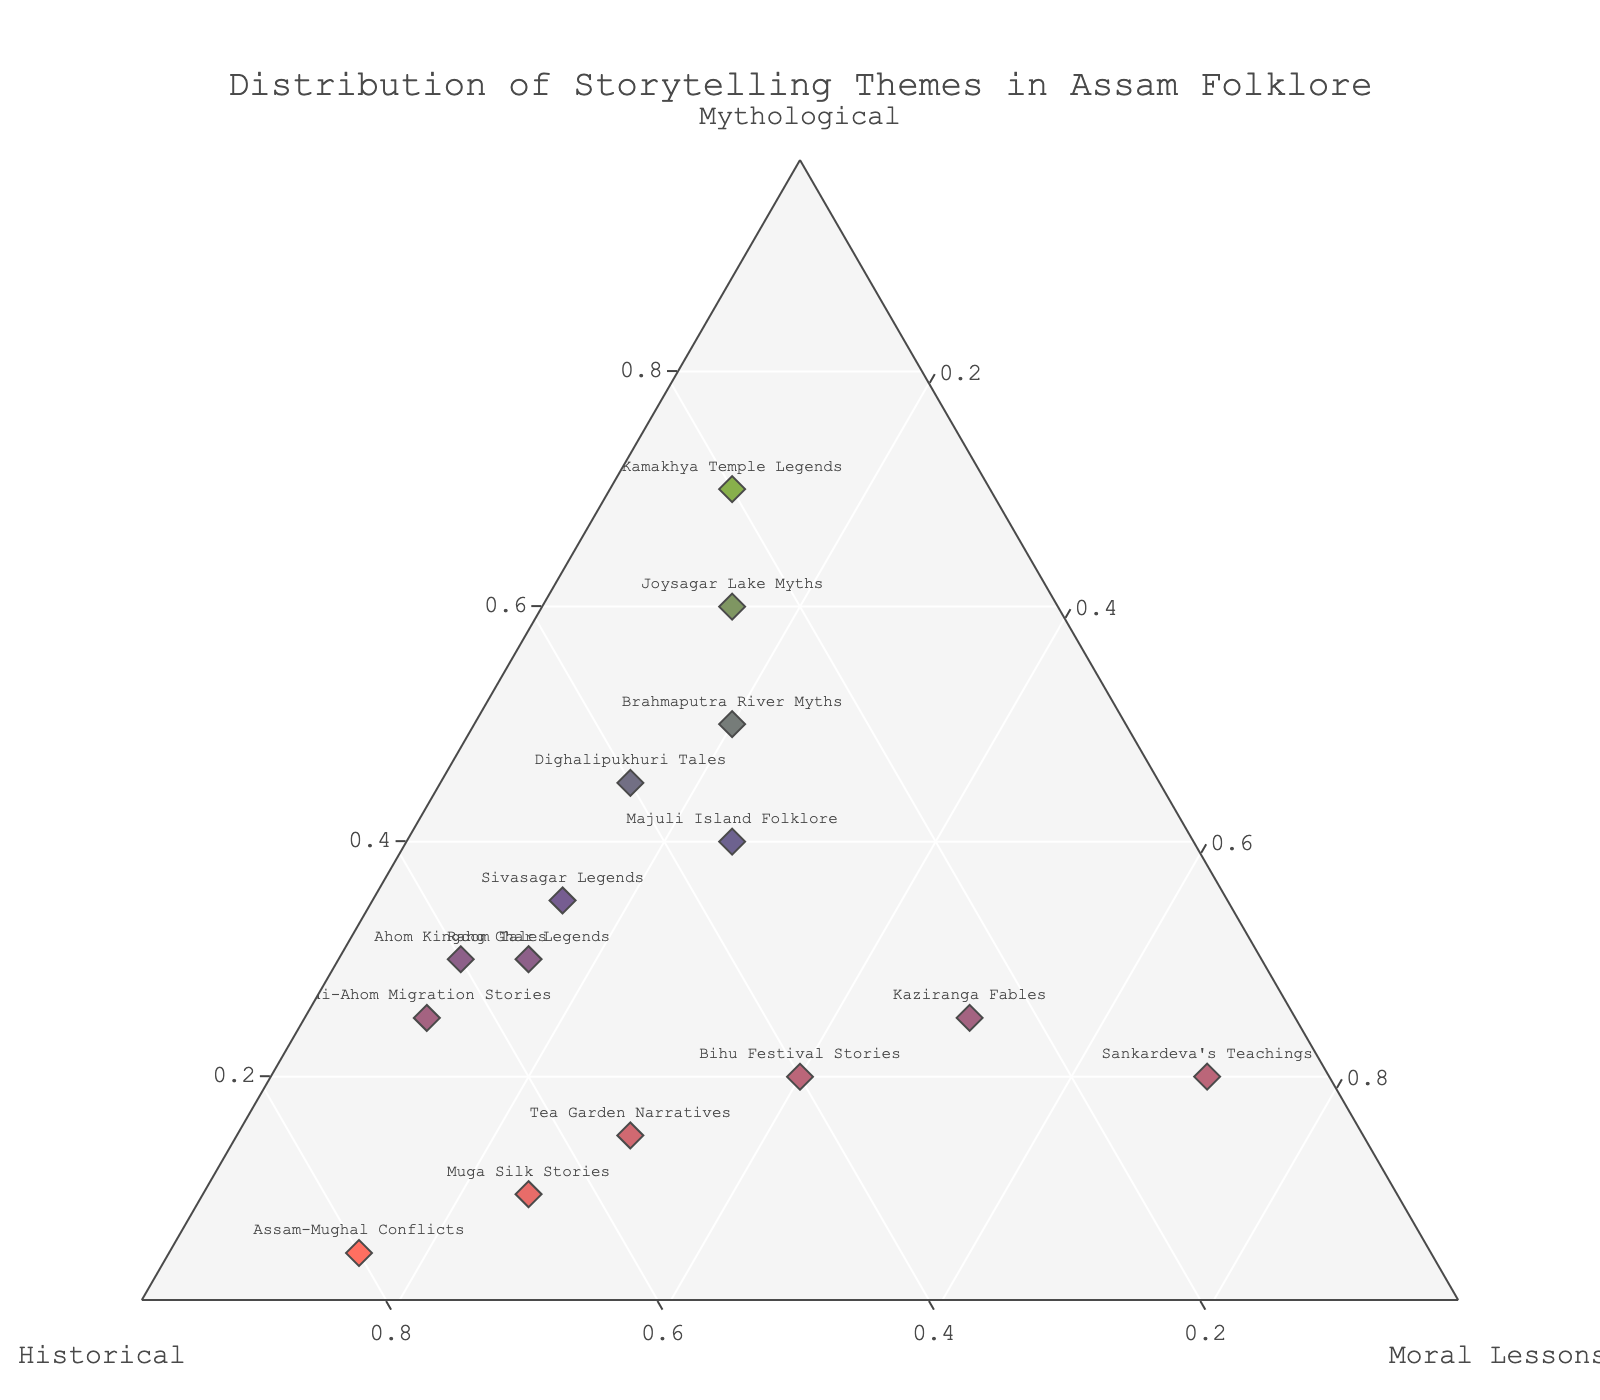Which storytelling theme focuses the most on mythological content? From the figure, we see that the Kamakhya Temple Legends datapoint is farthest along the Mythological axis compared to others. Its corresponding value for Mythological is the highest.
Answer: Kamakhya Temple Legends Which storytelling theme has the highest percentage dedicated to moral lessons? From the figure, Sankardeva's Teachings stands out as the point closest to the Moral Lessons axis. Its corresponding value for Moral Lessons is the highest.
Answer: Sankardeva's Teachings Which theme balances all three categories (mythological, historical, moral lessons) most evenly? Kaziranga Fables appears to be roughly equidistant from all three axes in the ternary plot, indicating a more balanced distribution among Mythological, Historical, and Moral Lessons.
Answer: Kaziranga Fables Which themes have the most historical content? The themes with the most historical content are Assam-Mughal Conflicts and Muga Silk Stories. These points are the farthest along the Historical axis.
Answer: Assam-Mughal Conflicts and Muga Silk Stories How does Joysagar Lake Myths compare in its mythological content with Brahmaputra River Myths? Comparing their positions on the Mythological axis, Joysagar Lake Myths has a higher value for mythological content compared to Brahmaputra River Myths.
Answer: Joysagar Lake Myths has more How many themes have at least 50% of their content focused on historical stories? The datapoints with historical content of 50% or more include Ahom Kingdom Tales, Tea Garden Narratives, Muga Silk Stories, Assam-Mughal Conflicts, and Tai-Ahom Migration Stories.
Answer: Five Which storytelling theme emphasizes moral lessons nearly as much as historical content? Tea Garden Narratives has a significant portion of its content dedicated to both moral lessons and historical content, with its values being 30 and 55, respectively.
Answer: Tea Garden Narratives Between Bihu Festival Stories and Sivasagar Legends, which theme has a higher percentage of moral lessons? From the plot, Bihu Festival Stories has a greater value for moral lessons compared to Sivasagar Legends, with values of 40 and 15, respectively.
Answer: Bihu Festival Stories What is the combined percentage of mythological and historical content in Majuli Island Folklore? Summing the values from the plot, the mythological content of Majuli Island Folklore is 40 and the historical content is 35, so the combined percentage is 40 + 35 = 75.
Answer: 75 Which storytelling themes share a similar pattern of distribution across mythological, historical, and moral lessons? Rang Ghar Legends and Ahom Kingdom Tales appear similar in their distribution, both emphasizing historical content significantly.
Answer: Rang Ghar Legends and Ahom Kingdom Tales 